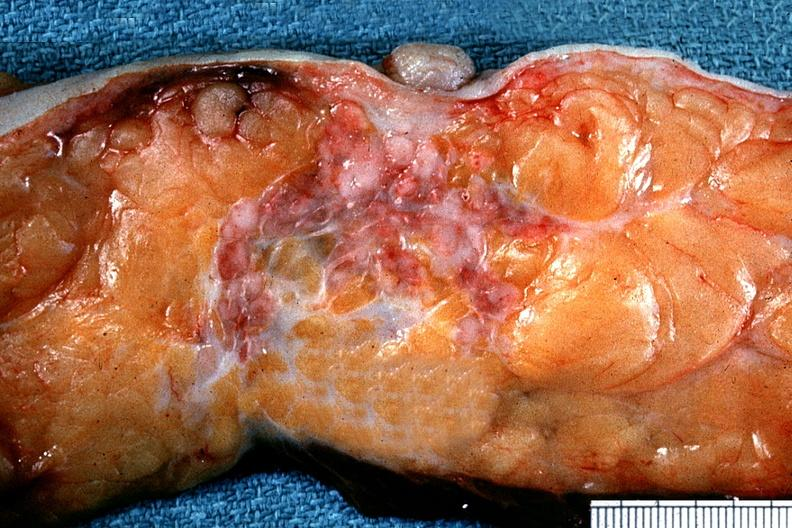s breast present?
Answer the question using a single word or phrase. No 